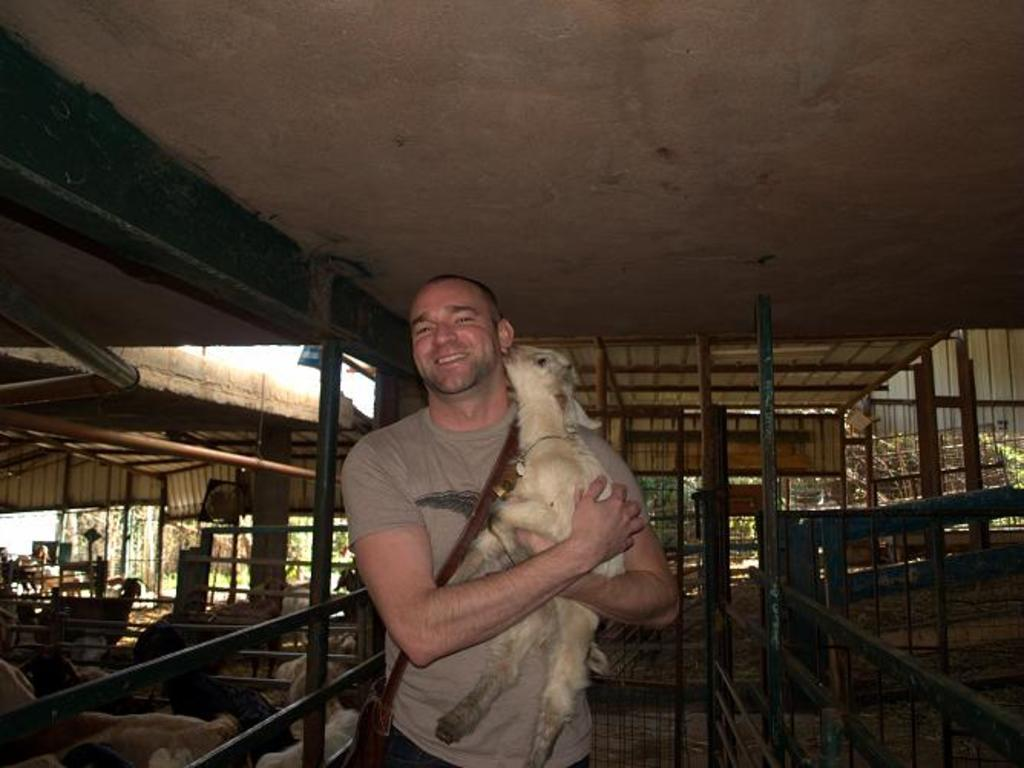What is the person in the image holding? The person is holding an animal in the image. What type of surface can be seen in the image? There is ground visible in the image. What other animals can be seen in the image besides the one being held? There are animals in the image. What type of barrier is present in the image? There is a fence in the image. What vertical structures can be seen in the image? There are poles in the image. What type of shelter is present in the image? There is a shed in the image. What part of the natural environment is visible in the image? The sky is visible in the image. What news headline is visible on the shed in the image? There is no news headline visible on the shed in the image. What type of coat is the person wearing in the image? The provided facts do not mention any clothing worn by the person in the image, so we cannot determine the type of coat they might be wearing. 